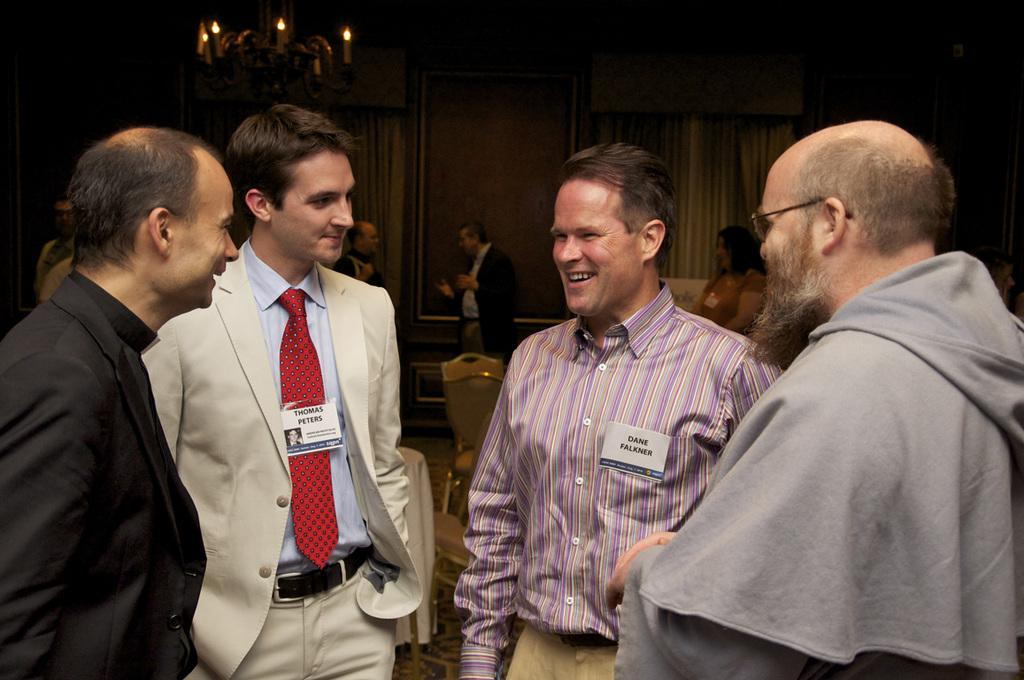How many men are in the image? There are four men in the image. What are the men doing in the image? The men are standing and smiling. What can be seen in the background of the image? There are chairs, a wall, curtains, and people visible in the background of the image. What is the degree of the vein in the image? There is no vein present in the image, so it is not possible to determine its degree. 